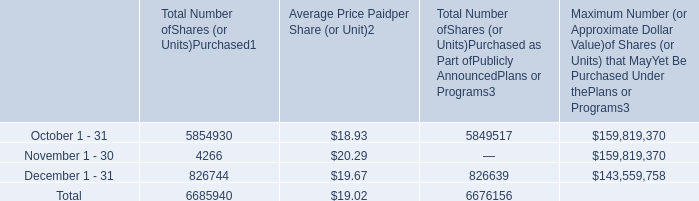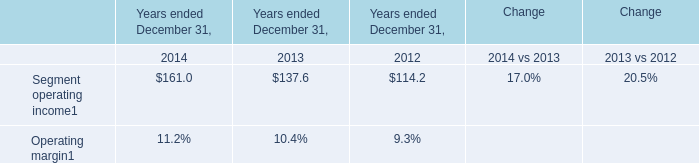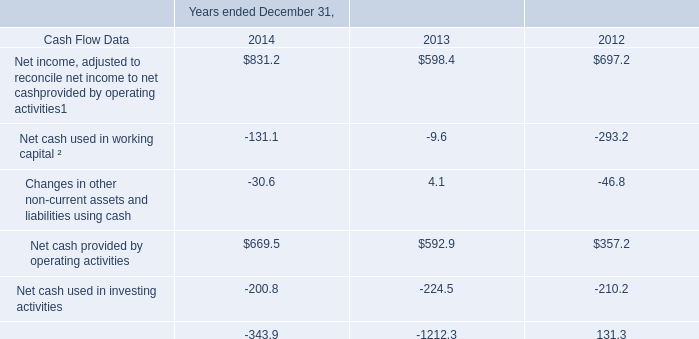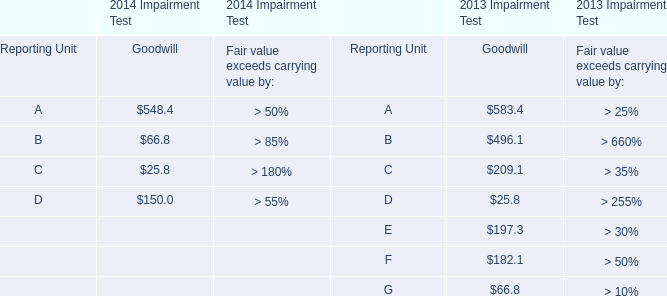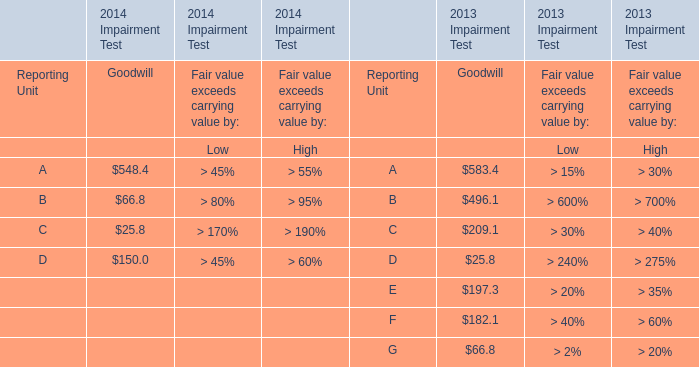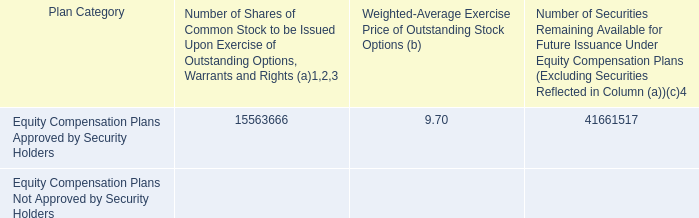with 2014 closing stock price , what is the total value of the award for the additional shares , ( in millions ) ? 
Computations: ((2721405 * 20.77) / 1000000)
Answer: 56.52358. 